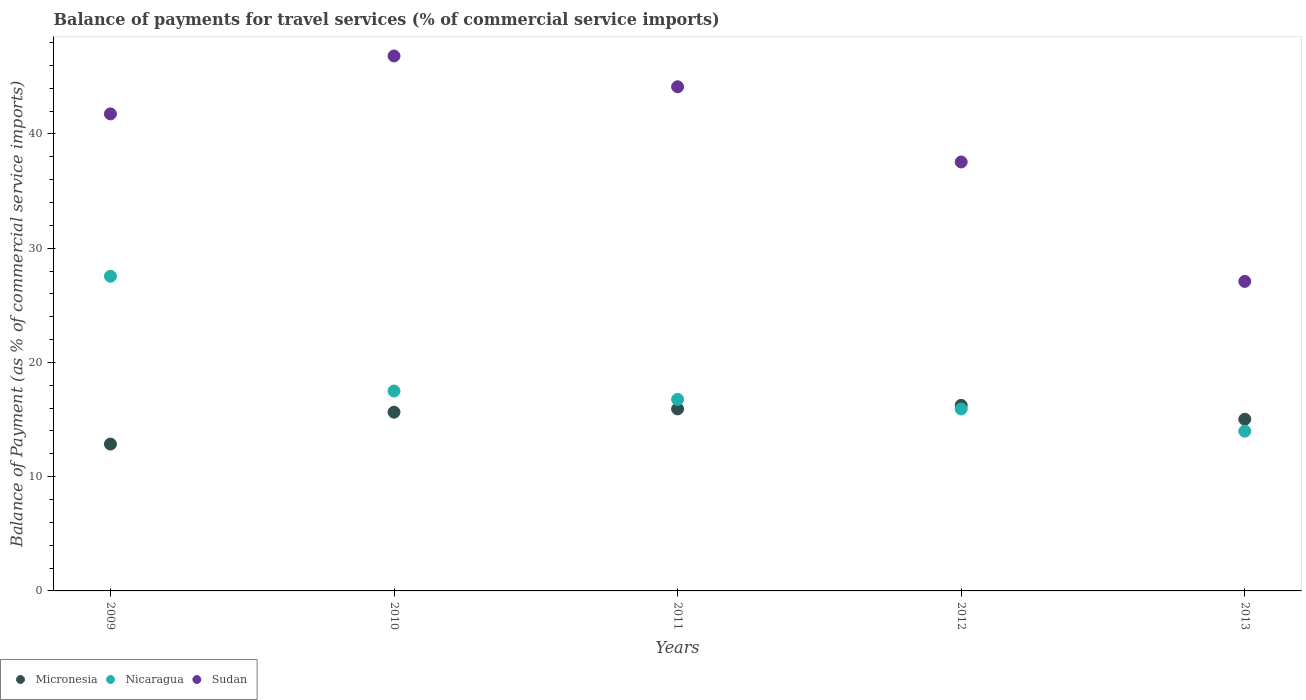How many different coloured dotlines are there?
Offer a very short reply. 3. Is the number of dotlines equal to the number of legend labels?
Give a very brief answer. Yes. What is the balance of payments for travel services in Micronesia in 2011?
Give a very brief answer. 15.93. Across all years, what is the maximum balance of payments for travel services in Micronesia?
Your response must be concise. 16.24. Across all years, what is the minimum balance of payments for travel services in Micronesia?
Provide a short and direct response. 12.85. In which year was the balance of payments for travel services in Nicaragua minimum?
Give a very brief answer. 2013. What is the total balance of payments for travel services in Micronesia in the graph?
Give a very brief answer. 75.69. What is the difference between the balance of payments for travel services in Nicaragua in 2010 and that in 2012?
Keep it short and to the point. 1.57. What is the difference between the balance of payments for travel services in Sudan in 2011 and the balance of payments for travel services in Nicaragua in 2012?
Your answer should be compact. 28.2. What is the average balance of payments for travel services in Nicaragua per year?
Keep it short and to the point. 18.34. In the year 2010, what is the difference between the balance of payments for travel services in Micronesia and balance of payments for travel services in Sudan?
Offer a very short reply. -31.18. In how many years, is the balance of payments for travel services in Sudan greater than 24 %?
Give a very brief answer. 5. What is the ratio of the balance of payments for travel services in Nicaragua in 2009 to that in 2010?
Ensure brevity in your answer.  1.57. Is the balance of payments for travel services in Sudan in 2009 less than that in 2012?
Your answer should be compact. No. Is the difference between the balance of payments for travel services in Micronesia in 2012 and 2013 greater than the difference between the balance of payments for travel services in Sudan in 2012 and 2013?
Ensure brevity in your answer.  No. What is the difference between the highest and the second highest balance of payments for travel services in Sudan?
Keep it short and to the point. 2.69. What is the difference between the highest and the lowest balance of payments for travel services in Nicaragua?
Ensure brevity in your answer.  13.56. In how many years, is the balance of payments for travel services in Sudan greater than the average balance of payments for travel services in Sudan taken over all years?
Offer a terse response. 3. Is it the case that in every year, the sum of the balance of payments for travel services in Sudan and balance of payments for travel services in Micronesia  is greater than the balance of payments for travel services in Nicaragua?
Make the answer very short. Yes. Does the balance of payments for travel services in Micronesia monotonically increase over the years?
Offer a terse response. No. Is the balance of payments for travel services in Sudan strictly less than the balance of payments for travel services in Nicaragua over the years?
Provide a short and direct response. No. How many dotlines are there?
Give a very brief answer. 3. What is the difference between two consecutive major ticks on the Y-axis?
Offer a terse response. 10. Are the values on the major ticks of Y-axis written in scientific E-notation?
Your answer should be very brief. No. Does the graph contain any zero values?
Provide a succinct answer. No. How are the legend labels stacked?
Provide a short and direct response. Horizontal. What is the title of the graph?
Offer a terse response. Balance of payments for travel services (% of commercial service imports). Does "American Samoa" appear as one of the legend labels in the graph?
Keep it short and to the point. No. What is the label or title of the Y-axis?
Make the answer very short. Balance of Payment (as % of commercial service imports). What is the Balance of Payment (as % of commercial service imports) in Micronesia in 2009?
Your answer should be compact. 12.85. What is the Balance of Payment (as % of commercial service imports) in Nicaragua in 2009?
Give a very brief answer. 27.54. What is the Balance of Payment (as % of commercial service imports) in Sudan in 2009?
Ensure brevity in your answer.  41.75. What is the Balance of Payment (as % of commercial service imports) in Micronesia in 2010?
Your response must be concise. 15.64. What is the Balance of Payment (as % of commercial service imports) in Nicaragua in 2010?
Give a very brief answer. 17.5. What is the Balance of Payment (as % of commercial service imports) of Sudan in 2010?
Offer a terse response. 46.82. What is the Balance of Payment (as % of commercial service imports) of Micronesia in 2011?
Ensure brevity in your answer.  15.93. What is the Balance of Payment (as % of commercial service imports) in Nicaragua in 2011?
Your answer should be very brief. 16.76. What is the Balance of Payment (as % of commercial service imports) of Sudan in 2011?
Keep it short and to the point. 44.13. What is the Balance of Payment (as % of commercial service imports) of Micronesia in 2012?
Offer a terse response. 16.24. What is the Balance of Payment (as % of commercial service imports) of Nicaragua in 2012?
Your answer should be very brief. 15.93. What is the Balance of Payment (as % of commercial service imports) in Sudan in 2012?
Offer a terse response. 37.54. What is the Balance of Payment (as % of commercial service imports) of Micronesia in 2013?
Provide a short and direct response. 15.03. What is the Balance of Payment (as % of commercial service imports) in Nicaragua in 2013?
Your answer should be compact. 13.98. What is the Balance of Payment (as % of commercial service imports) in Sudan in 2013?
Offer a very short reply. 27.09. Across all years, what is the maximum Balance of Payment (as % of commercial service imports) of Micronesia?
Offer a terse response. 16.24. Across all years, what is the maximum Balance of Payment (as % of commercial service imports) of Nicaragua?
Your answer should be compact. 27.54. Across all years, what is the maximum Balance of Payment (as % of commercial service imports) of Sudan?
Make the answer very short. 46.82. Across all years, what is the minimum Balance of Payment (as % of commercial service imports) in Micronesia?
Your answer should be compact. 12.85. Across all years, what is the minimum Balance of Payment (as % of commercial service imports) of Nicaragua?
Provide a short and direct response. 13.98. Across all years, what is the minimum Balance of Payment (as % of commercial service imports) in Sudan?
Offer a very short reply. 27.09. What is the total Balance of Payment (as % of commercial service imports) in Micronesia in the graph?
Ensure brevity in your answer.  75.69. What is the total Balance of Payment (as % of commercial service imports) in Nicaragua in the graph?
Provide a short and direct response. 91.71. What is the total Balance of Payment (as % of commercial service imports) of Sudan in the graph?
Give a very brief answer. 197.33. What is the difference between the Balance of Payment (as % of commercial service imports) of Micronesia in 2009 and that in 2010?
Your answer should be compact. -2.79. What is the difference between the Balance of Payment (as % of commercial service imports) in Nicaragua in 2009 and that in 2010?
Give a very brief answer. 10.04. What is the difference between the Balance of Payment (as % of commercial service imports) of Sudan in 2009 and that in 2010?
Keep it short and to the point. -5.07. What is the difference between the Balance of Payment (as % of commercial service imports) in Micronesia in 2009 and that in 2011?
Make the answer very short. -3.08. What is the difference between the Balance of Payment (as % of commercial service imports) of Nicaragua in 2009 and that in 2011?
Make the answer very short. 10.78. What is the difference between the Balance of Payment (as % of commercial service imports) of Sudan in 2009 and that in 2011?
Offer a terse response. -2.37. What is the difference between the Balance of Payment (as % of commercial service imports) of Micronesia in 2009 and that in 2012?
Keep it short and to the point. -3.39. What is the difference between the Balance of Payment (as % of commercial service imports) in Nicaragua in 2009 and that in 2012?
Ensure brevity in your answer.  11.62. What is the difference between the Balance of Payment (as % of commercial service imports) in Sudan in 2009 and that in 2012?
Make the answer very short. 4.21. What is the difference between the Balance of Payment (as % of commercial service imports) in Micronesia in 2009 and that in 2013?
Your answer should be compact. -2.17. What is the difference between the Balance of Payment (as % of commercial service imports) of Nicaragua in 2009 and that in 2013?
Your response must be concise. 13.56. What is the difference between the Balance of Payment (as % of commercial service imports) of Sudan in 2009 and that in 2013?
Offer a terse response. 14.66. What is the difference between the Balance of Payment (as % of commercial service imports) in Micronesia in 2010 and that in 2011?
Ensure brevity in your answer.  -0.29. What is the difference between the Balance of Payment (as % of commercial service imports) in Nicaragua in 2010 and that in 2011?
Give a very brief answer. 0.73. What is the difference between the Balance of Payment (as % of commercial service imports) of Sudan in 2010 and that in 2011?
Ensure brevity in your answer.  2.69. What is the difference between the Balance of Payment (as % of commercial service imports) in Micronesia in 2010 and that in 2012?
Give a very brief answer. -0.6. What is the difference between the Balance of Payment (as % of commercial service imports) of Nicaragua in 2010 and that in 2012?
Your answer should be compact. 1.57. What is the difference between the Balance of Payment (as % of commercial service imports) of Sudan in 2010 and that in 2012?
Make the answer very short. 9.28. What is the difference between the Balance of Payment (as % of commercial service imports) of Micronesia in 2010 and that in 2013?
Provide a short and direct response. 0.62. What is the difference between the Balance of Payment (as % of commercial service imports) in Nicaragua in 2010 and that in 2013?
Your answer should be compact. 3.52. What is the difference between the Balance of Payment (as % of commercial service imports) of Sudan in 2010 and that in 2013?
Your answer should be compact. 19.73. What is the difference between the Balance of Payment (as % of commercial service imports) in Micronesia in 2011 and that in 2012?
Your answer should be compact. -0.31. What is the difference between the Balance of Payment (as % of commercial service imports) of Nicaragua in 2011 and that in 2012?
Provide a succinct answer. 0.84. What is the difference between the Balance of Payment (as % of commercial service imports) in Sudan in 2011 and that in 2012?
Provide a short and direct response. 6.58. What is the difference between the Balance of Payment (as % of commercial service imports) in Micronesia in 2011 and that in 2013?
Offer a terse response. 0.9. What is the difference between the Balance of Payment (as % of commercial service imports) in Nicaragua in 2011 and that in 2013?
Give a very brief answer. 2.78. What is the difference between the Balance of Payment (as % of commercial service imports) in Sudan in 2011 and that in 2013?
Your answer should be compact. 17.04. What is the difference between the Balance of Payment (as % of commercial service imports) of Micronesia in 2012 and that in 2013?
Provide a succinct answer. 1.22. What is the difference between the Balance of Payment (as % of commercial service imports) of Nicaragua in 2012 and that in 2013?
Provide a succinct answer. 1.94. What is the difference between the Balance of Payment (as % of commercial service imports) in Sudan in 2012 and that in 2013?
Provide a succinct answer. 10.45. What is the difference between the Balance of Payment (as % of commercial service imports) of Micronesia in 2009 and the Balance of Payment (as % of commercial service imports) of Nicaragua in 2010?
Your answer should be compact. -4.64. What is the difference between the Balance of Payment (as % of commercial service imports) of Micronesia in 2009 and the Balance of Payment (as % of commercial service imports) of Sudan in 2010?
Offer a terse response. -33.97. What is the difference between the Balance of Payment (as % of commercial service imports) of Nicaragua in 2009 and the Balance of Payment (as % of commercial service imports) of Sudan in 2010?
Make the answer very short. -19.28. What is the difference between the Balance of Payment (as % of commercial service imports) in Micronesia in 2009 and the Balance of Payment (as % of commercial service imports) in Nicaragua in 2011?
Make the answer very short. -3.91. What is the difference between the Balance of Payment (as % of commercial service imports) of Micronesia in 2009 and the Balance of Payment (as % of commercial service imports) of Sudan in 2011?
Your response must be concise. -31.27. What is the difference between the Balance of Payment (as % of commercial service imports) in Nicaragua in 2009 and the Balance of Payment (as % of commercial service imports) in Sudan in 2011?
Offer a very short reply. -16.58. What is the difference between the Balance of Payment (as % of commercial service imports) of Micronesia in 2009 and the Balance of Payment (as % of commercial service imports) of Nicaragua in 2012?
Your answer should be compact. -3.07. What is the difference between the Balance of Payment (as % of commercial service imports) in Micronesia in 2009 and the Balance of Payment (as % of commercial service imports) in Sudan in 2012?
Your answer should be very brief. -24.69. What is the difference between the Balance of Payment (as % of commercial service imports) of Nicaragua in 2009 and the Balance of Payment (as % of commercial service imports) of Sudan in 2012?
Your response must be concise. -10. What is the difference between the Balance of Payment (as % of commercial service imports) of Micronesia in 2009 and the Balance of Payment (as % of commercial service imports) of Nicaragua in 2013?
Your answer should be very brief. -1.13. What is the difference between the Balance of Payment (as % of commercial service imports) in Micronesia in 2009 and the Balance of Payment (as % of commercial service imports) in Sudan in 2013?
Provide a short and direct response. -14.24. What is the difference between the Balance of Payment (as % of commercial service imports) in Nicaragua in 2009 and the Balance of Payment (as % of commercial service imports) in Sudan in 2013?
Give a very brief answer. 0.45. What is the difference between the Balance of Payment (as % of commercial service imports) of Micronesia in 2010 and the Balance of Payment (as % of commercial service imports) of Nicaragua in 2011?
Ensure brevity in your answer.  -1.12. What is the difference between the Balance of Payment (as % of commercial service imports) of Micronesia in 2010 and the Balance of Payment (as % of commercial service imports) of Sudan in 2011?
Give a very brief answer. -28.48. What is the difference between the Balance of Payment (as % of commercial service imports) of Nicaragua in 2010 and the Balance of Payment (as % of commercial service imports) of Sudan in 2011?
Your answer should be very brief. -26.63. What is the difference between the Balance of Payment (as % of commercial service imports) in Micronesia in 2010 and the Balance of Payment (as % of commercial service imports) in Nicaragua in 2012?
Offer a very short reply. -0.28. What is the difference between the Balance of Payment (as % of commercial service imports) of Micronesia in 2010 and the Balance of Payment (as % of commercial service imports) of Sudan in 2012?
Ensure brevity in your answer.  -21.9. What is the difference between the Balance of Payment (as % of commercial service imports) in Nicaragua in 2010 and the Balance of Payment (as % of commercial service imports) in Sudan in 2012?
Your response must be concise. -20.05. What is the difference between the Balance of Payment (as % of commercial service imports) of Micronesia in 2010 and the Balance of Payment (as % of commercial service imports) of Nicaragua in 2013?
Offer a terse response. 1.66. What is the difference between the Balance of Payment (as % of commercial service imports) in Micronesia in 2010 and the Balance of Payment (as % of commercial service imports) in Sudan in 2013?
Your answer should be very brief. -11.45. What is the difference between the Balance of Payment (as % of commercial service imports) of Nicaragua in 2010 and the Balance of Payment (as % of commercial service imports) of Sudan in 2013?
Provide a short and direct response. -9.59. What is the difference between the Balance of Payment (as % of commercial service imports) of Micronesia in 2011 and the Balance of Payment (as % of commercial service imports) of Nicaragua in 2012?
Make the answer very short. 0. What is the difference between the Balance of Payment (as % of commercial service imports) in Micronesia in 2011 and the Balance of Payment (as % of commercial service imports) in Sudan in 2012?
Offer a very short reply. -21.61. What is the difference between the Balance of Payment (as % of commercial service imports) in Nicaragua in 2011 and the Balance of Payment (as % of commercial service imports) in Sudan in 2012?
Your answer should be compact. -20.78. What is the difference between the Balance of Payment (as % of commercial service imports) in Micronesia in 2011 and the Balance of Payment (as % of commercial service imports) in Nicaragua in 2013?
Ensure brevity in your answer.  1.95. What is the difference between the Balance of Payment (as % of commercial service imports) in Micronesia in 2011 and the Balance of Payment (as % of commercial service imports) in Sudan in 2013?
Ensure brevity in your answer.  -11.16. What is the difference between the Balance of Payment (as % of commercial service imports) in Nicaragua in 2011 and the Balance of Payment (as % of commercial service imports) in Sudan in 2013?
Your response must be concise. -10.33. What is the difference between the Balance of Payment (as % of commercial service imports) in Micronesia in 2012 and the Balance of Payment (as % of commercial service imports) in Nicaragua in 2013?
Offer a terse response. 2.26. What is the difference between the Balance of Payment (as % of commercial service imports) of Micronesia in 2012 and the Balance of Payment (as % of commercial service imports) of Sudan in 2013?
Give a very brief answer. -10.85. What is the difference between the Balance of Payment (as % of commercial service imports) of Nicaragua in 2012 and the Balance of Payment (as % of commercial service imports) of Sudan in 2013?
Your response must be concise. -11.16. What is the average Balance of Payment (as % of commercial service imports) of Micronesia per year?
Your answer should be compact. 15.14. What is the average Balance of Payment (as % of commercial service imports) in Nicaragua per year?
Your response must be concise. 18.34. What is the average Balance of Payment (as % of commercial service imports) of Sudan per year?
Keep it short and to the point. 39.47. In the year 2009, what is the difference between the Balance of Payment (as % of commercial service imports) in Micronesia and Balance of Payment (as % of commercial service imports) in Nicaragua?
Provide a succinct answer. -14.69. In the year 2009, what is the difference between the Balance of Payment (as % of commercial service imports) of Micronesia and Balance of Payment (as % of commercial service imports) of Sudan?
Provide a short and direct response. -28.9. In the year 2009, what is the difference between the Balance of Payment (as % of commercial service imports) of Nicaragua and Balance of Payment (as % of commercial service imports) of Sudan?
Ensure brevity in your answer.  -14.21. In the year 2010, what is the difference between the Balance of Payment (as % of commercial service imports) in Micronesia and Balance of Payment (as % of commercial service imports) in Nicaragua?
Ensure brevity in your answer.  -1.86. In the year 2010, what is the difference between the Balance of Payment (as % of commercial service imports) of Micronesia and Balance of Payment (as % of commercial service imports) of Sudan?
Provide a short and direct response. -31.18. In the year 2010, what is the difference between the Balance of Payment (as % of commercial service imports) of Nicaragua and Balance of Payment (as % of commercial service imports) of Sudan?
Offer a terse response. -29.32. In the year 2011, what is the difference between the Balance of Payment (as % of commercial service imports) in Micronesia and Balance of Payment (as % of commercial service imports) in Nicaragua?
Your response must be concise. -0.83. In the year 2011, what is the difference between the Balance of Payment (as % of commercial service imports) in Micronesia and Balance of Payment (as % of commercial service imports) in Sudan?
Keep it short and to the point. -28.2. In the year 2011, what is the difference between the Balance of Payment (as % of commercial service imports) of Nicaragua and Balance of Payment (as % of commercial service imports) of Sudan?
Your response must be concise. -27.36. In the year 2012, what is the difference between the Balance of Payment (as % of commercial service imports) in Micronesia and Balance of Payment (as % of commercial service imports) in Nicaragua?
Make the answer very short. 0.32. In the year 2012, what is the difference between the Balance of Payment (as % of commercial service imports) in Micronesia and Balance of Payment (as % of commercial service imports) in Sudan?
Keep it short and to the point. -21.3. In the year 2012, what is the difference between the Balance of Payment (as % of commercial service imports) in Nicaragua and Balance of Payment (as % of commercial service imports) in Sudan?
Make the answer very short. -21.62. In the year 2013, what is the difference between the Balance of Payment (as % of commercial service imports) in Micronesia and Balance of Payment (as % of commercial service imports) in Nicaragua?
Provide a short and direct response. 1.04. In the year 2013, what is the difference between the Balance of Payment (as % of commercial service imports) of Micronesia and Balance of Payment (as % of commercial service imports) of Sudan?
Your response must be concise. -12.06. In the year 2013, what is the difference between the Balance of Payment (as % of commercial service imports) of Nicaragua and Balance of Payment (as % of commercial service imports) of Sudan?
Offer a very short reply. -13.11. What is the ratio of the Balance of Payment (as % of commercial service imports) in Micronesia in 2009 to that in 2010?
Offer a terse response. 0.82. What is the ratio of the Balance of Payment (as % of commercial service imports) of Nicaragua in 2009 to that in 2010?
Provide a succinct answer. 1.57. What is the ratio of the Balance of Payment (as % of commercial service imports) in Sudan in 2009 to that in 2010?
Provide a short and direct response. 0.89. What is the ratio of the Balance of Payment (as % of commercial service imports) in Micronesia in 2009 to that in 2011?
Your response must be concise. 0.81. What is the ratio of the Balance of Payment (as % of commercial service imports) in Nicaragua in 2009 to that in 2011?
Provide a succinct answer. 1.64. What is the ratio of the Balance of Payment (as % of commercial service imports) in Sudan in 2009 to that in 2011?
Offer a terse response. 0.95. What is the ratio of the Balance of Payment (as % of commercial service imports) of Micronesia in 2009 to that in 2012?
Provide a short and direct response. 0.79. What is the ratio of the Balance of Payment (as % of commercial service imports) in Nicaragua in 2009 to that in 2012?
Ensure brevity in your answer.  1.73. What is the ratio of the Balance of Payment (as % of commercial service imports) of Sudan in 2009 to that in 2012?
Keep it short and to the point. 1.11. What is the ratio of the Balance of Payment (as % of commercial service imports) in Micronesia in 2009 to that in 2013?
Your response must be concise. 0.86. What is the ratio of the Balance of Payment (as % of commercial service imports) in Nicaragua in 2009 to that in 2013?
Offer a terse response. 1.97. What is the ratio of the Balance of Payment (as % of commercial service imports) of Sudan in 2009 to that in 2013?
Provide a succinct answer. 1.54. What is the ratio of the Balance of Payment (as % of commercial service imports) of Micronesia in 2010 to that in 2011?
Ensure brevity in your answer.  0.98. What is the ratio of the Balance of Payment (as % of commercial service imports) in Nicaragua in 2010 to that in 2011?
Give a very brief answer. 1.04. What is the ratio of the Balance of Payment (as % of commercial service imports) of Sudan in 2010 to that in 2011?
Give a very brief answer. 1.06. What is the ratio of the Balance of Payment (as % of commercial service imports) of Nicaragua in 2010 to that in 2012?
Provide a succinct answer. 1.1. What is the ratio of the Balance of Payment (as % of commercial service imports) of Sudan in 2010 to that in 2012?
Offer a very short reply. 1.25. What is the ratio of the Balance of Payment (as % of commercial service imports) in Micronesia in 2010 to that in 2013?
Keep it short and to the point. 1.04. What is the ratio of the Balance of Payment (as % of commercial service imports) of Nicaragua in 2010 to that in 2013?
Provide a succinct answer. 1.25. What is the ratio of the Balance of Payment (as % of commercial service imports) of Sudan in 2010 to that in 2013?
Your answer should be very brief. 1.73. What is the ratio of the Balance of Payment (as % of commercial service imports) of Micronesia in 2011 to that in 2012?
Keep it short and to the point. 0.98. What is the ratio of the Balance of Payment (as % of commercial service imports) of Nicaragua in 2011 to that in 2012?
Offer a very short reply. 1.05. What is the ratio of the Balance of Payment (as % of commercial service imports) in Sudan in 2011 to that in 2012?
Provide a short and direct response. 1.18. What is the ratio of the Balance of Payment (as % of commercial service imports) of Micronesia in 2011 to that in 2013?
Keep it short and to the point. 1.06. What is the ratio of the Balance of Payment (as % of commercial service imports) of Nicaragua in 2011 to that in 2013?
Your answer should be very brief. 1.2. What is the ratio of the Balance of Payment (as % of commercial service imports) of Sudan in 2011 to that in 2013?
Provide a succinct answer. 1.63. What is the ratio of the Balance of Payment (as % of commercial service imports) in Micronesia in 2012 to that in 2013?
Provide a succinct answer. 1.08. What is the ratio of the Balance of Payment (as % of commercial service imports) in Nicaragua in 2012 to that in 2013?
Offer a terse response. 1.14. What is the ratio of the Balance of Payment (as % of commercial service imports) of Sudan in 2012 to that in 2013?
Ensure brevity in your answer.  1.39. What is the difference between the highest and the second highest Balance of Payment (as % of commercial service imports) of Micronesia?
Make the answer very short. 0.31. What is the difference between the highest and the second highest Balance of Payment (as % of commercial service imports) in Nicaragua?
Offer a terse response. 10.04. What is the difference between the highest and the second highest Balance of Payment (as % of commercial service imports) of Sudan?
Keep it short and to the point. 2.69. What is the difference between the highest and the lowest Balance of Payment (as % of commercial service imports) of Micronesia?
Ensure brevity in your answer.  3.39. What is the difference between the highest and the lowest Balance of Payment (as % of commercial service imports) of Nicaragua?
Your response must be concise. 13.56. What is the difference between the highest and the lowest Balance of Payment (as % of commercial service imports) of Sudan?
Your answer should be compact. 19.73. 